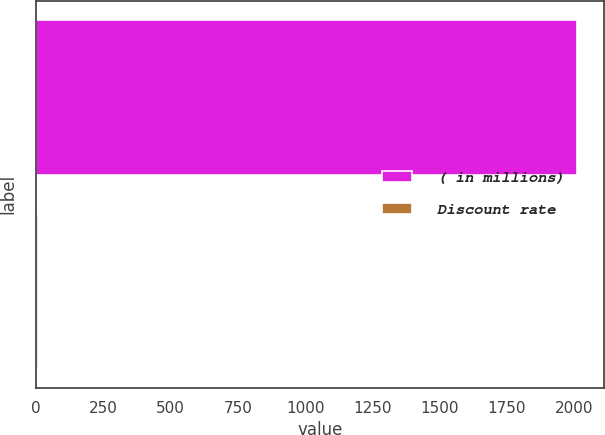<chart> <loc_0><loc_0><loc_500><loc_500><bar_chart><fcel>( in millions)<fcel>Discount rate<nl><fcel>2011<fcel>5.23<nl></chart> 